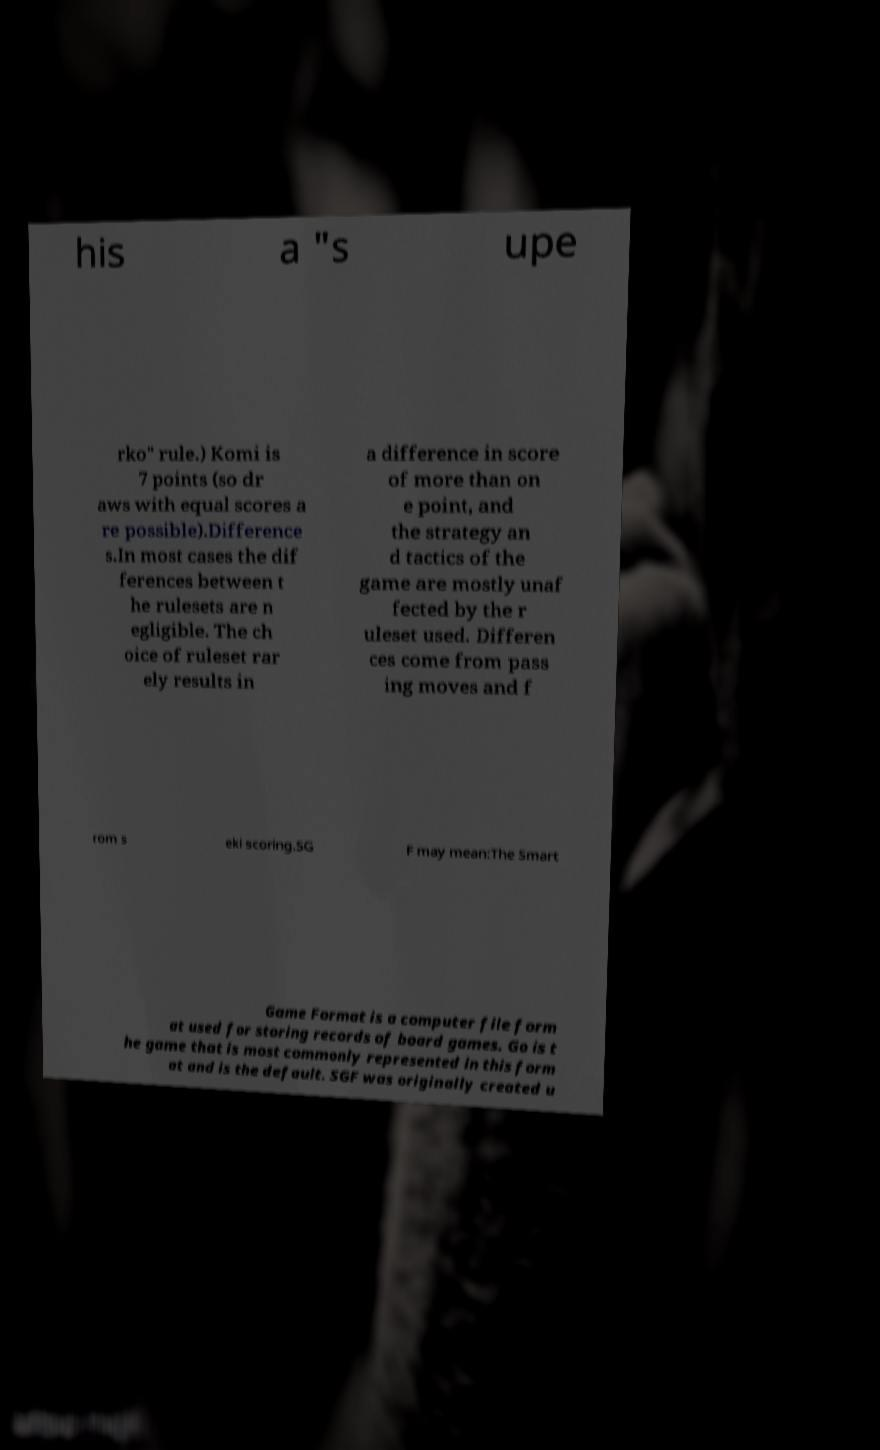For documentation purposes, I need the text within this image transcribed. Could you provide that? his a "s upe rko" rule.) Komi is 7 points (so dr aws with equal scores a re possible).Difference s.In most cases the dif ferences between t he rulesets are n egligible. The ch oice of ruleset rar ely results in a difference in score of more than on e point, and the strategy an d tactics of the game are mostly unaf fected by the r uleset used. Differen ces come from pass ing moves and f rom s eki scoring.SG F may mean:The Smart Game Format is a computer file form at used for storing records of board games. Go is t he game that is most commonly represented in this form at and is the default. SGF was originally created u 